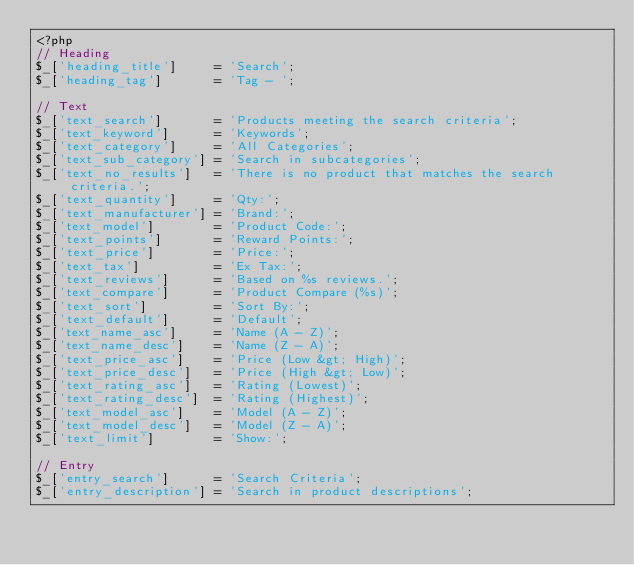<code> <loc_0><loc_0><loc_500><loc_500><_PHP_><?php
// Heading
$_['heading_title']     = 'Search';
$_['heading_tag']       = 'Tag - ';

// Text
$_['text_search']       = 'Products meeting the search criteria';
$_['text_keyword']      = 'Keywords';
$_['text_category']     = 'All Categories';
$_['text_sub_category'] = 'Search in subcategories';
$_['text_no_results']   = 'There is no product that matches the search criteria.';
$_['text_quantity']     = 'Qty:';
$_['text_manufacturer'] = 'Brand:';
$_['text_model']        = 'Product Code:';
$_['text_points']       = 'Reward Points:';
$_['text_price']        = 'Price:';
$_['text_tax']          = 'Ex Tax:';
$_['text_reviews']      = 'Based on %s reviews.';
$_['text_compare']      = 'Product Compare (%s)';
$_['text_sort']         = 'Sort By:';
$_['text_default']      = 'Default';
$_['text_name_asc']     = 'Name (A - Z)';
$_['text_name_desc']    = 'Name (Z - A)';
$_['text_price_asc']    = 'Price (Low &gt; High)';
$_['text_price_desc']   = 'Price (High &gt; Low)';
$_['text_rating_asc']   = 'Rating (Lowest)';
$_['text_rating_desc']  = 'Rating (Highest)';
$_['text_model_asc']    = 'Model (A - Z)';
$_['text_model_desc']   = 'Model (Z - A)';
$_['text_limit']        = 'Show:';

// Entry
$_['entry_search']      = 'Search Criteria';
$_['entry_description'] = 'Search in product descriptions';</code> 